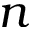<formula> <loc_0><loc_0><loc_500><loc_500>n</formula> 